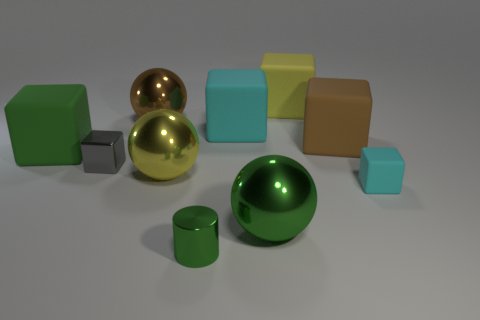There is a big cube that is the same color as the small cylinder; what material is it?
Provide a succinct answer. Rubber. Does the cyan matte thing in front of the big cyan matte cube have the same shape as the green matte object?
Make the answer very short. Yes. What number of objects are small cylinders or red matte spheres?
Keep it short and to the point. 1. Is the material of the cyan cube that is behind the green rubber block the same as the large yellow block?
Your answer should be compact. Yes. What is the size of the green sphere?
Provide a succinct answer. Large. What shape is the big matte thing that is the same color as the cylinder?
Your answer should be very brief. Cube. How many blocks are small cyan things or yellow things?
Keep it short and to the point. 2. Is the number of metallic spheres to the right of the brown block the same as the number of metallic balls that are in front of the big brown sphere?
Your answer should be compact. No. What is the size of the gray object that is the same shape as the large cyan thing?
Ensure brevity in your answer.  Small. There is a object that is both in front of the small cyan cube and right of the small green cylinder; what is its size?
Your response must be concise. Large. 